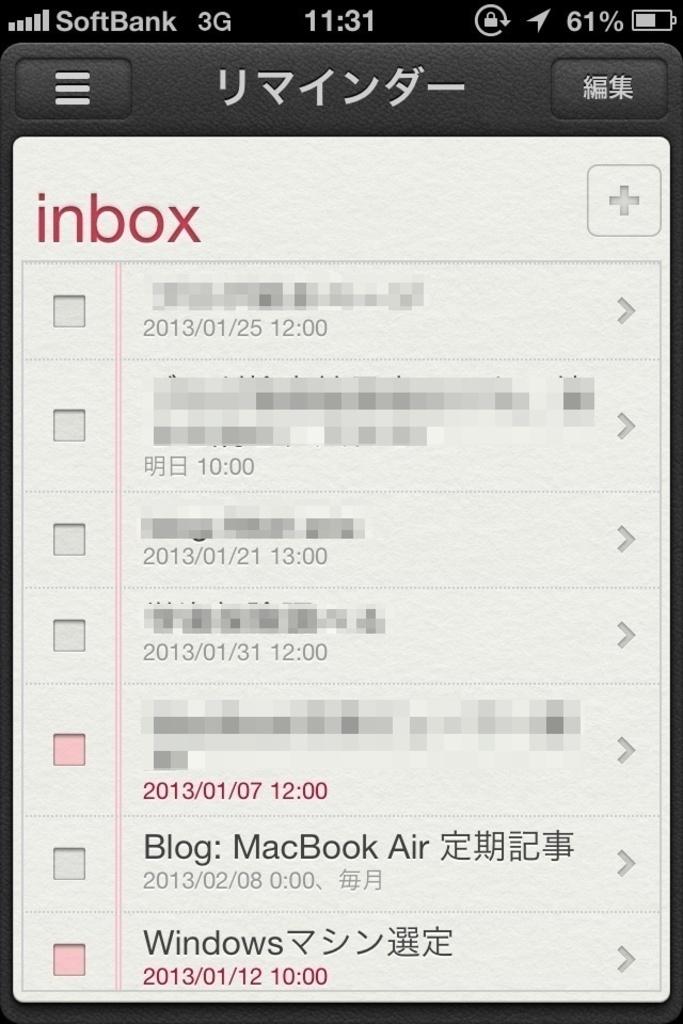What does the top option with the orange icon say?
Ensure brevity in your answer.  Unanswerable. What type of computer is associated with the blog entry?
Ensure brevity in your answer.  Macbook air. 